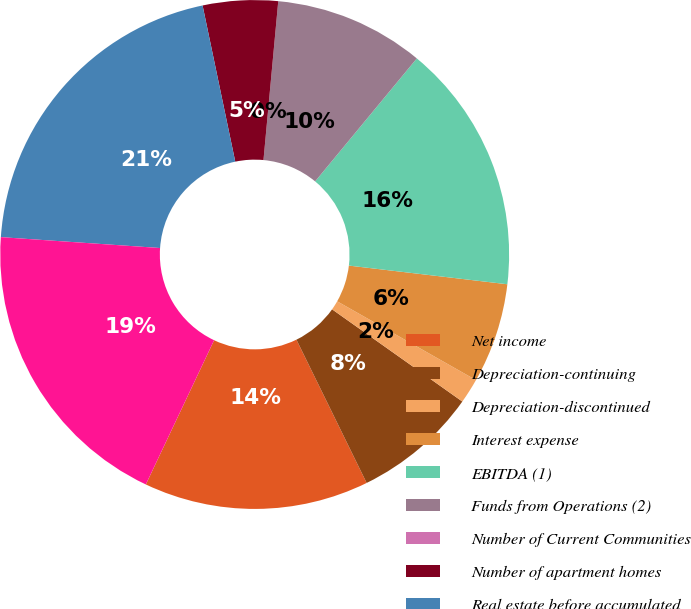Convert chart. <chart><loc_0><loc_0><loc_500><loc_500><pie_chart><fcel>Net income<fcel>Depreciation-continuing<fcel>Depreciation-discontinued<fcel>Interest expense<fcel>EBITDA (1)<fcel>Funds from Operations (2)<fcel>Number of Current Communities<fcel>Number of apartment homes<fcel>Real estate before accumulated<fcel>Total assets<nl><fcel>14.29%<fcel>7.94%<fcel>1.59%<fcel>6.35%<fcel>15.87%<fcel>9.52%<fcel>0.0%<fcel>4.76%<fcel>20.63%<fcel>19.05%<nl></chart> 